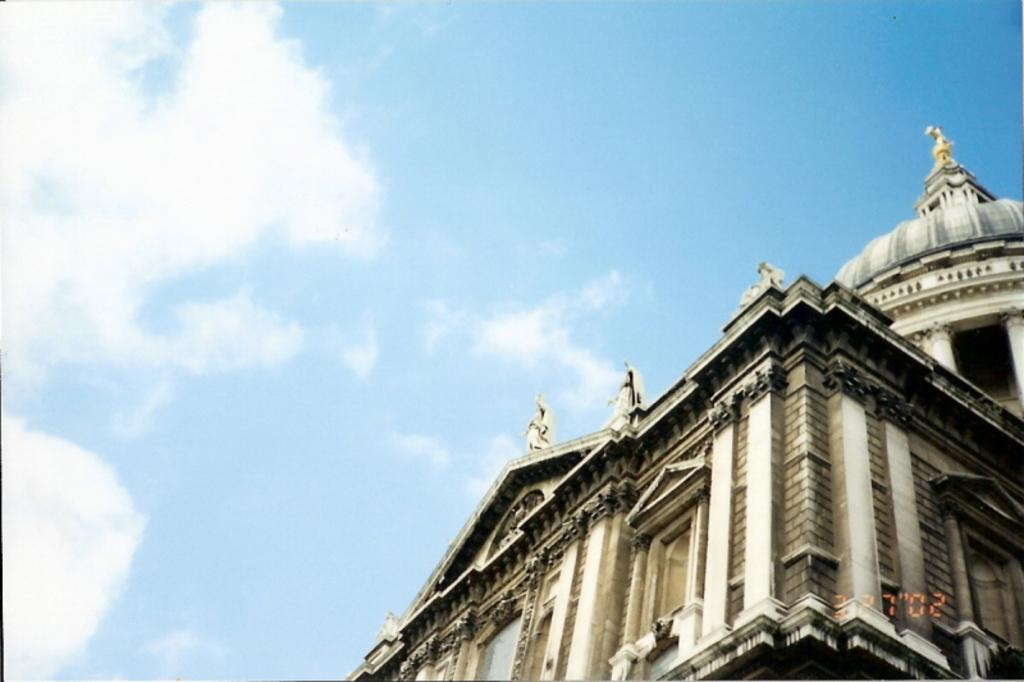What is the main structure visible in the image? There is a building in the image. Are there any decorative elements on the building? Yes, there are statues on the building. What can be seen in the sky in the image? There are clouds in the sky in the image. What type of caption is written on the building in the image? There is no caption visible on the building in the image. What kind of treatment is being administered to the plants in the image? There are no plants present in the image, so no treatment can be observed. 